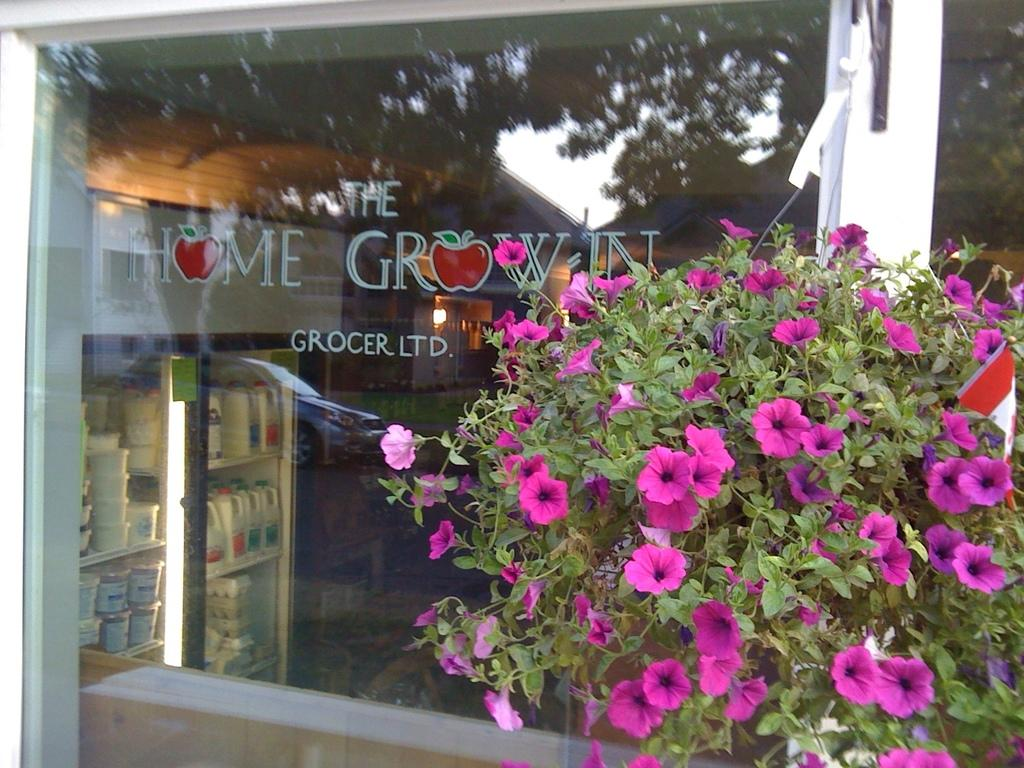What type of plant is on the right side of the image? There is a plant on the right side of the image, and it has flowers. What can be seen in the background of the image? There is a store in the background of the image. What is visible through the glass in the store? A refrigerator is visible through the glass in the store. Is there a hole in the plant's leaves in the image? There is no mention of a hole in the plant's leaves in the image. Can you see a stream flowing near the store in the image? There is no mention of a stream in the image; it only shows a plant, a store, and a refrigerator visible through the glass. 